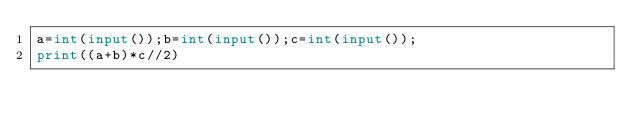Convert code to text. <code><loc_0><loc_0><loc_500><loc_500><_Python_>a=int(input());b=int(input());c=int(input());
print((a+b)*c//2)</code> 